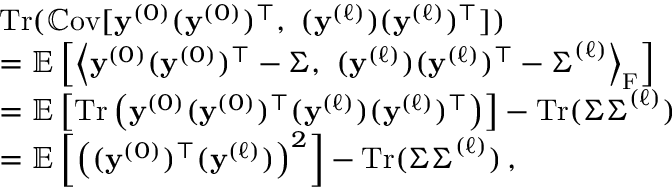<formula> <loc_0><loc_0><loc_500><loc_500>\begin{array} { r l } & { T r ( \mathbb { C } o v [ { y } ^ { ( 0 ) } ( { y } ^ { ( 0 ) } ) ^ { \top } , \ ( { y } ^ { ( \ell ) } ) ( { y } ^ { ( \ell ) } ) ^ { \top } ] ) } \\ & { = \mathbb { E } \left [ \left \langle { y } ^ { ( 0 ) } ( { y } ^ { ( 0 ) } ) ^ { \top } - { \Sigma } , \ ( { y } ^ { ( \ell ) } ) ( { y } ^ { ( \ell ) } ) ^ { \top } - { \Sigma } ^ { ( \ell ) } \right \rangle _ { F } \right ] } \\ & { = \mathbb { E } \left [ T r \left ( { y } ^ { ( 0 ) } ( { y } ^ { ( 0 ) } ) ^ { \top } ( { y } ^ { ( \ell ) } ) ( { y } ^ { ( \ell ) } ) ^ { \top } \right ) \right ] - T r ( { \Sigma } { \Sigma } ^ { ( \ell ) } ) } \\ & { = \mathbb { E } \left [ \left ( ( { y } ^ { ( 0 ) } ) ^ { \top } ( { y } ^ { ( \ell ) } ) \right ) ^ { 2 } \right ] - T r ( { \Sigma } { \Sigma } ^ { ( \ell ) } ) \, , } \end{array}</formula> 